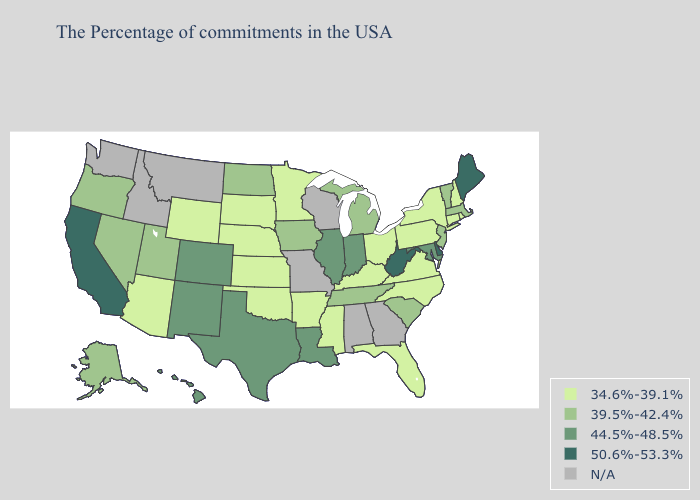What is the highest value in states that border Nebraska?
Quick response, please. 44.5%-48.5%. Among the states that border Idaho , does Utah have the lowest value?
Concise answer only. No. What is the value of Arkansas?
Short answer required. 34.6%-39.1%. Name the states that have a value in the range 34.6%-39.1%?
Quick response, please. Rhode Island, New Hampshire, Connecticut, New York, Pennsylvania, Virginia, North Carolina, Ohio, Florida, Kentucky, Mississippi, Arkansas, Minnesota, Kansas, Nebraska, Oklahoma, South Dakota, Wyoming, Arizona. Does Maine have the highest value in the Northeast?
Write a very short answer. Yes. Does New Mexico have the lowest value in the USA?
Answer briefly. No. Which states have the lowest value in the USA?
Quick response, please. Rhode Island, New Hampshire, Connecticut, New York, Pennsylvania, Virginia, North Carolina, Ohio, Florida, Kentucky, Mississippi, Arkansas, Minnesota, Kansas, Nebraska, Oklahoma, South Dakota, Wyoming, Arizona. Does Louisiana have the highest value in the USA?
Short answer required. No. What is the lowest value in states that border Minnesota?
Answer briefly. 34.6%-39.1%. Among the states that border West Virginia , which have the lowest value?
Give a very brief answer. Pennsylvania, Virginia, Ohio, Kentucky. Which states have the lowest value in the USA?
Quick response, please. Rhode Island, New Hampshire, Connecticut, New York, Pennsylvania, Virginia, North Carolina, Ohio, Florida, Kentucky, Mississippi, Arkansas, Minnesota, Kansas, Nebraska, Oklahoma, South Dakota, Wyoming, Arizona. Does the map have missing data?
Write a very short answer. Yes. What is the value of California?
Write a very short answer. 50.6%-53.3%. 